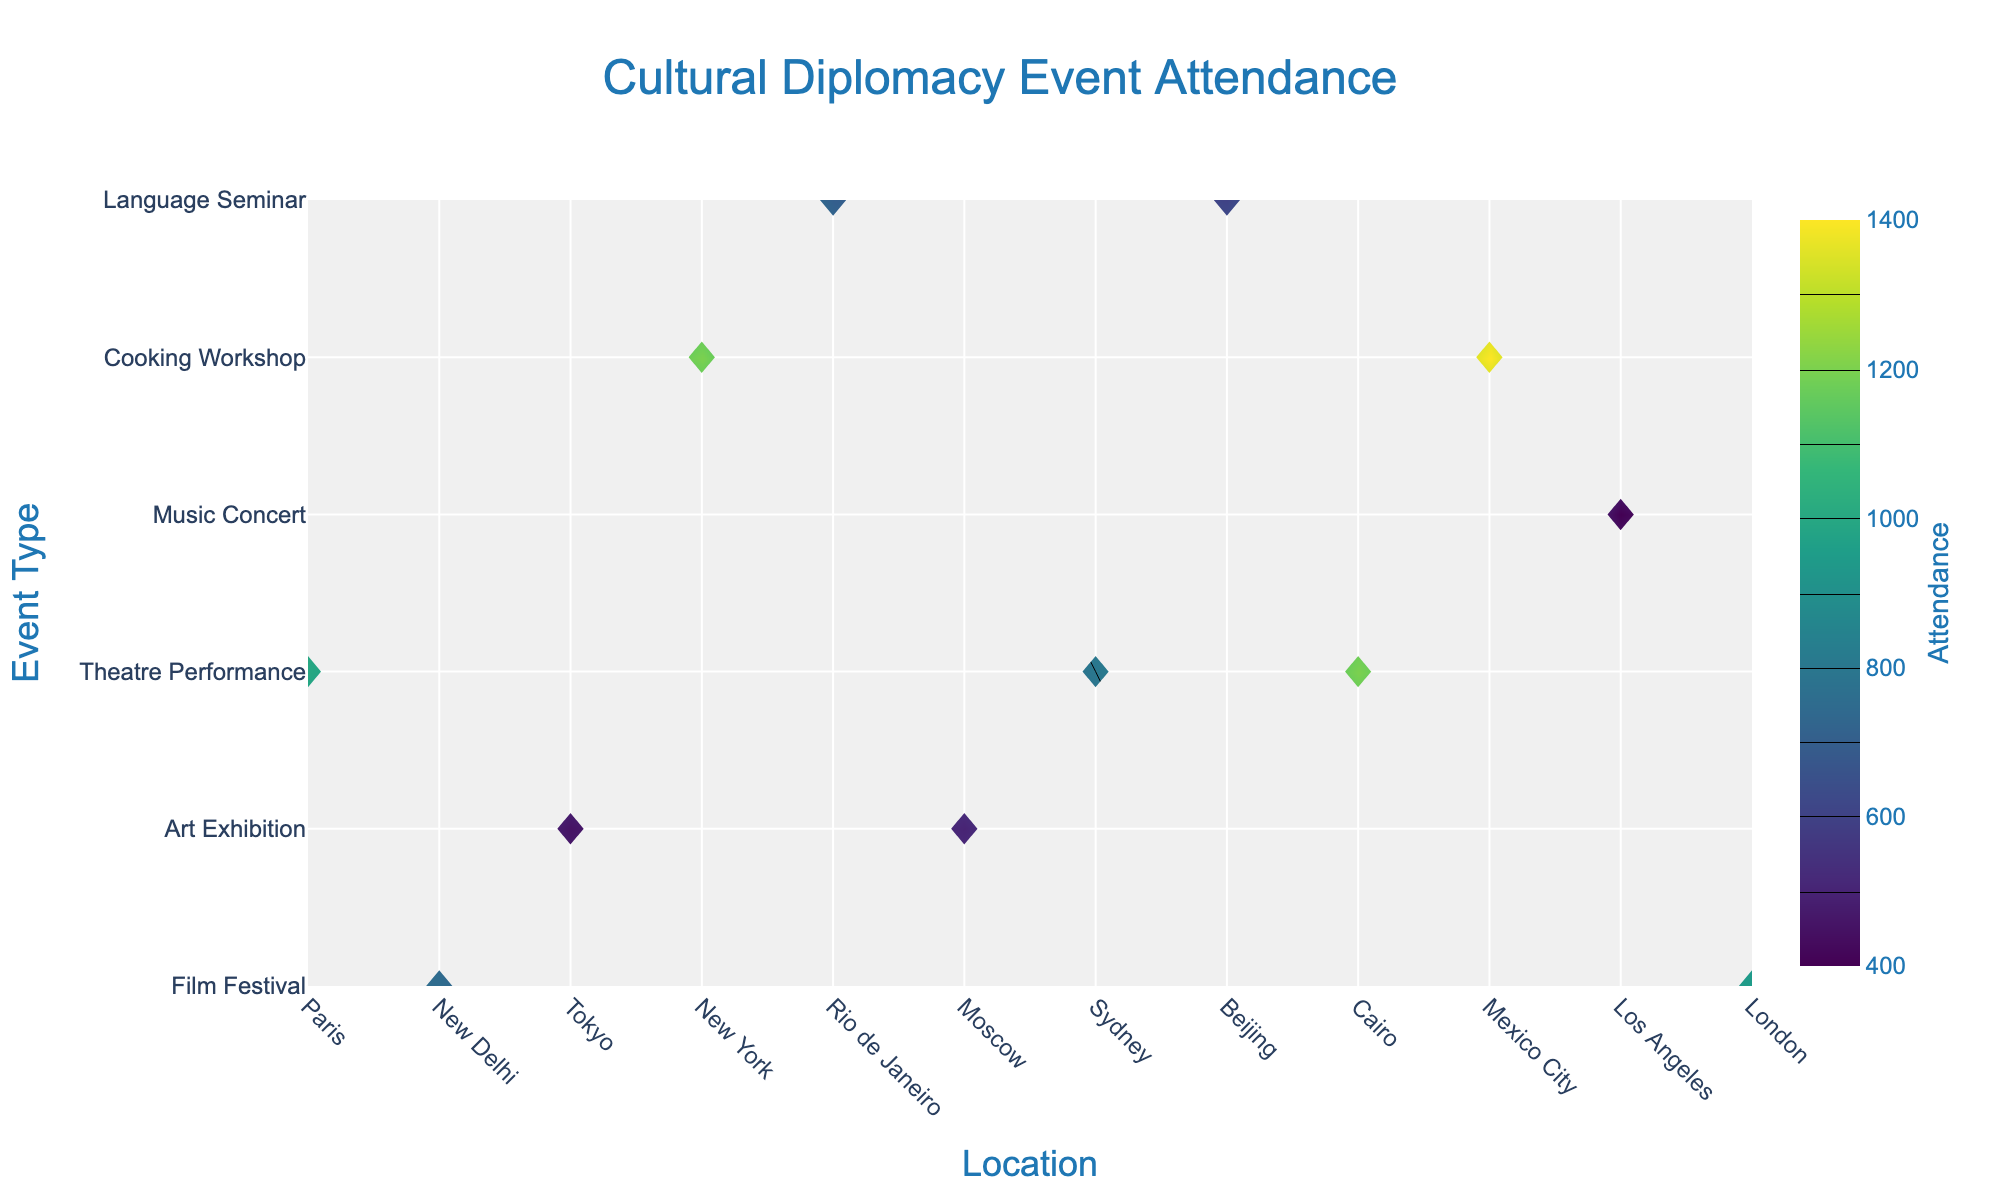Which event had the highest attendance? Look at the figure and find the event type with the highest contour color intensity, and refer to the label.
Answer: Music Concert in Rio de Janeiro Which city hosted the event with the lowest attendance? Identify the location corresponding to the lowest contour color intensity on the plot, then refer to the label.
Answer: Sydney How does the attendance for Film Festivals vary across different locations? By examining the contour plot, trace the lines for "Film Festival" and compare across different locations based on attendance values and color intensity.
Answer: Paris: 1200, New Delhi: 800, Beijing: 1000 What is the difference in attendance between the highest and lowest attended events? Pick the maximum attendance value (Music Concert in Rio de Janeiro: 1400) and the minimum attendance value (Language Seminar in Sydney: 400), then compute the difference.
Answer: 1000 Which event type showed the least variation in attendance across all locations? Look at the contour plot and identify which event type has the closest color intensity values across different locations.
Answer: Theatre Performance What's the average attendance of Art Exhibitions across all locations? Check the attendance values for "Art Exhibition" and calculate the average: (950+750)/2.
Answer: 850 Between Cooking Workshops in June in Moscow and December in London, which had higher attendance? Compare the color intensity levels and labels for Cooking Workshop in Moscow and London.
Answer: Moscow Which location had the highest overall attendance for events (sum of attendances across all event types)? Sum the attendance values of all events for each location and identify the maximum.
Answer: Rio de Janeiro: 1400 How many locations had more than 1000 attendees for their events? Count the number of locations with attendance values exceeding 1000 by analyzing the color levels and labels.
Answer: Four locations Is there a trend in attendance based on the month of the event? Extract the months and corresponding attendance values from the contour plot, then assess if there's a notable pattern by month.
Answer: No clear trend 